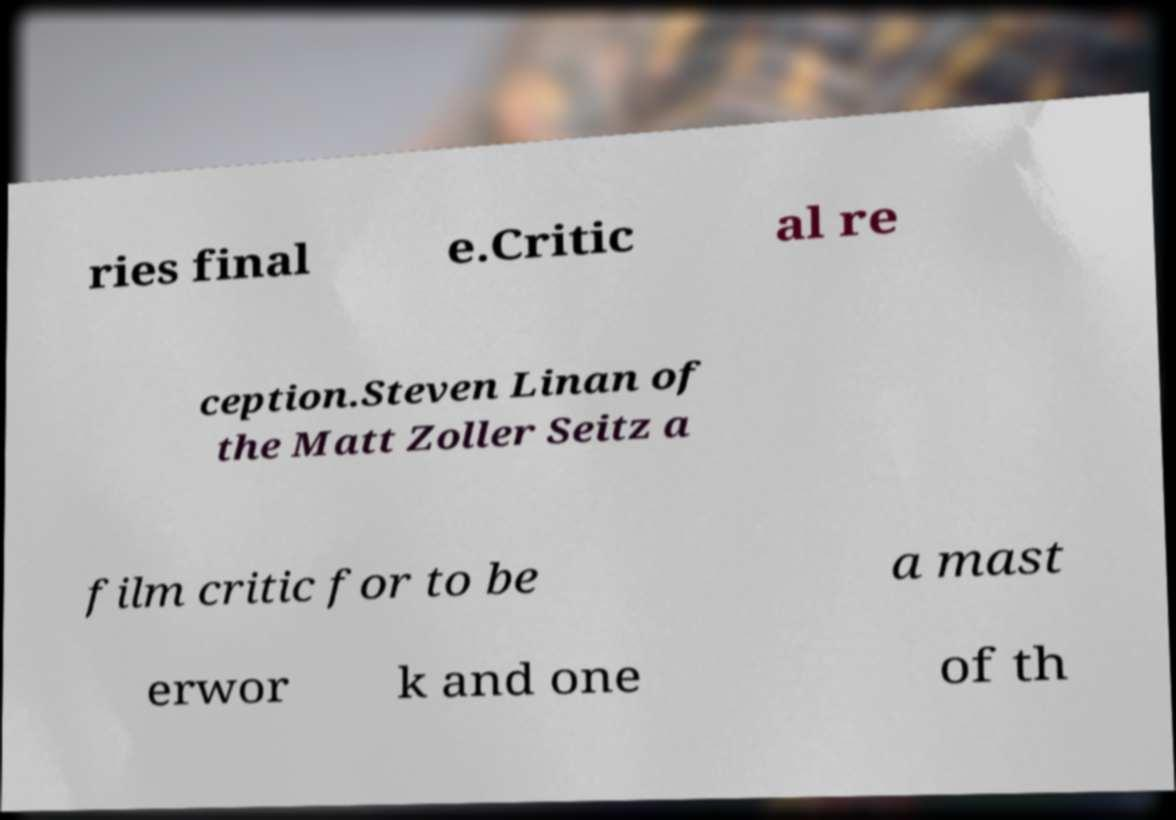For documentation purposes, I need the text within this image transcribed. Could you provide that? ries final e.Critic al re ception.Steven Linan of the Matt Zoller Seitz a film critic for to be a mast erwor k and one of th 